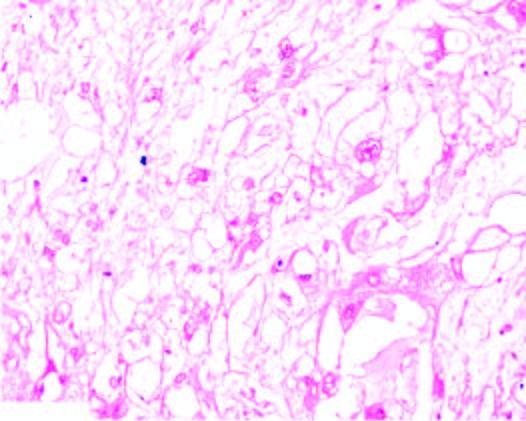what is myxoid?
Answer the question using a single word or phrase. Background 